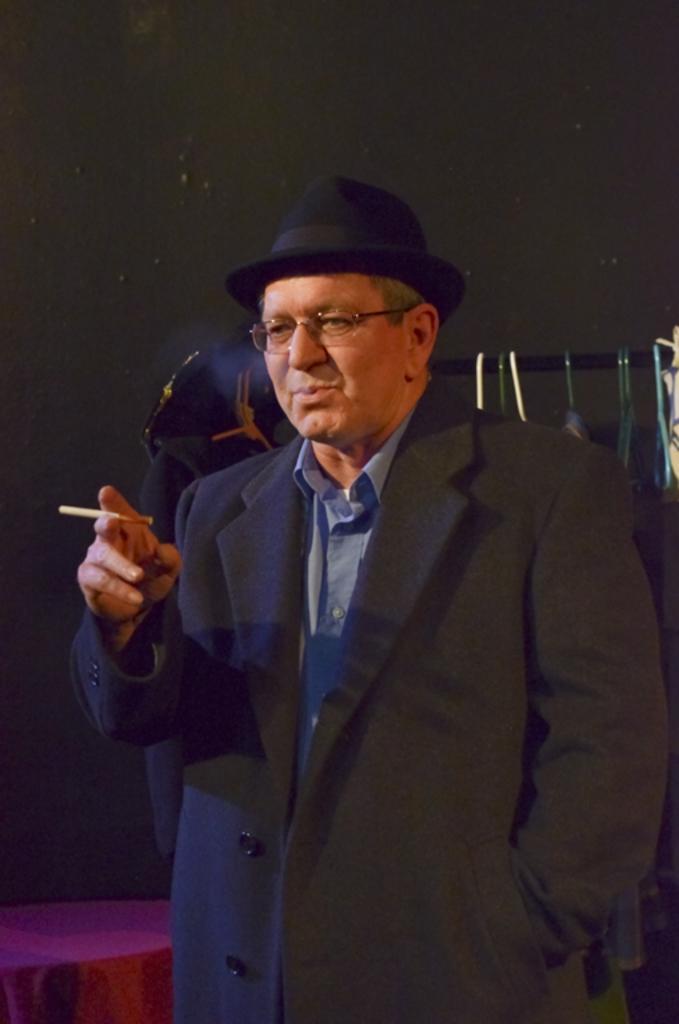Could you give a brief overview of what you see in this image? Here we can see a man. He is in a suit and he has spectacles. In the background there is a wall. 